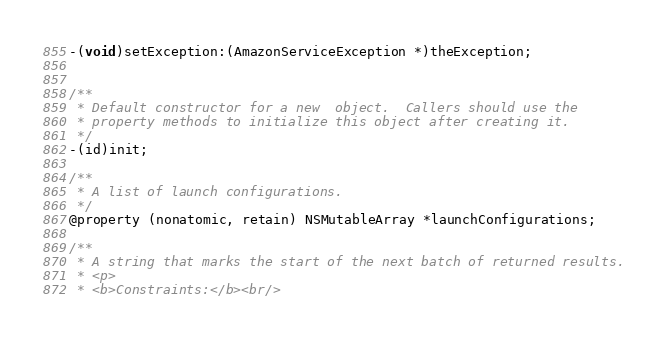Convert code to text. <code><loc_0><loc_0><loc_500><loc_500><_C_>-(void)setException:(AmazonServiceException *)theException;


/**
 * Default constructor for a new  object.  Callers should use the
 * property methods to initialize this object after creating it.
 */
-(id)init;

/**
 * A list of launch configurations.
 */
@property (nonatomic, retain) NSMutableArray *launchConfigurations;

/**
 * A string that marks the start of the next batch of returned results.
 * <p>
 * <b>Constraints:</b><br/></code> 